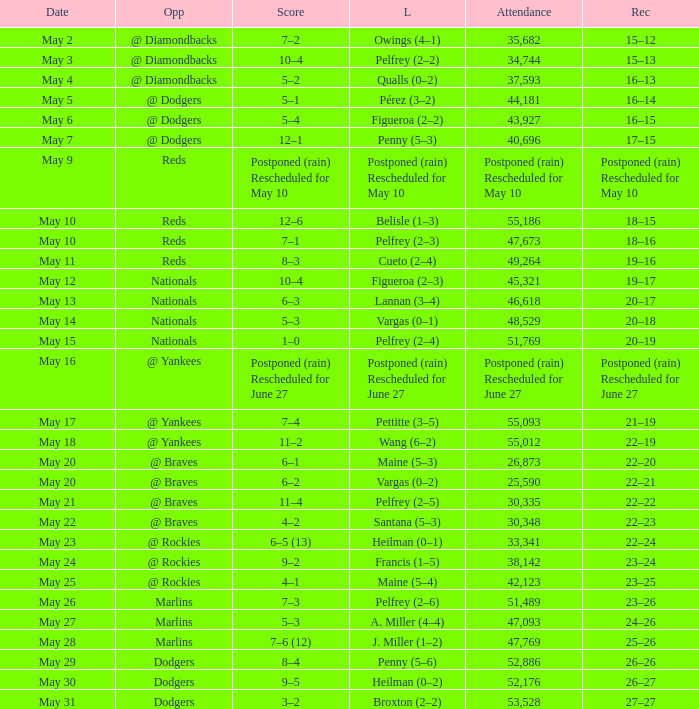Opponent of @ braves, and a Loss of pelfrey (2–5) had what score? 11–4. 